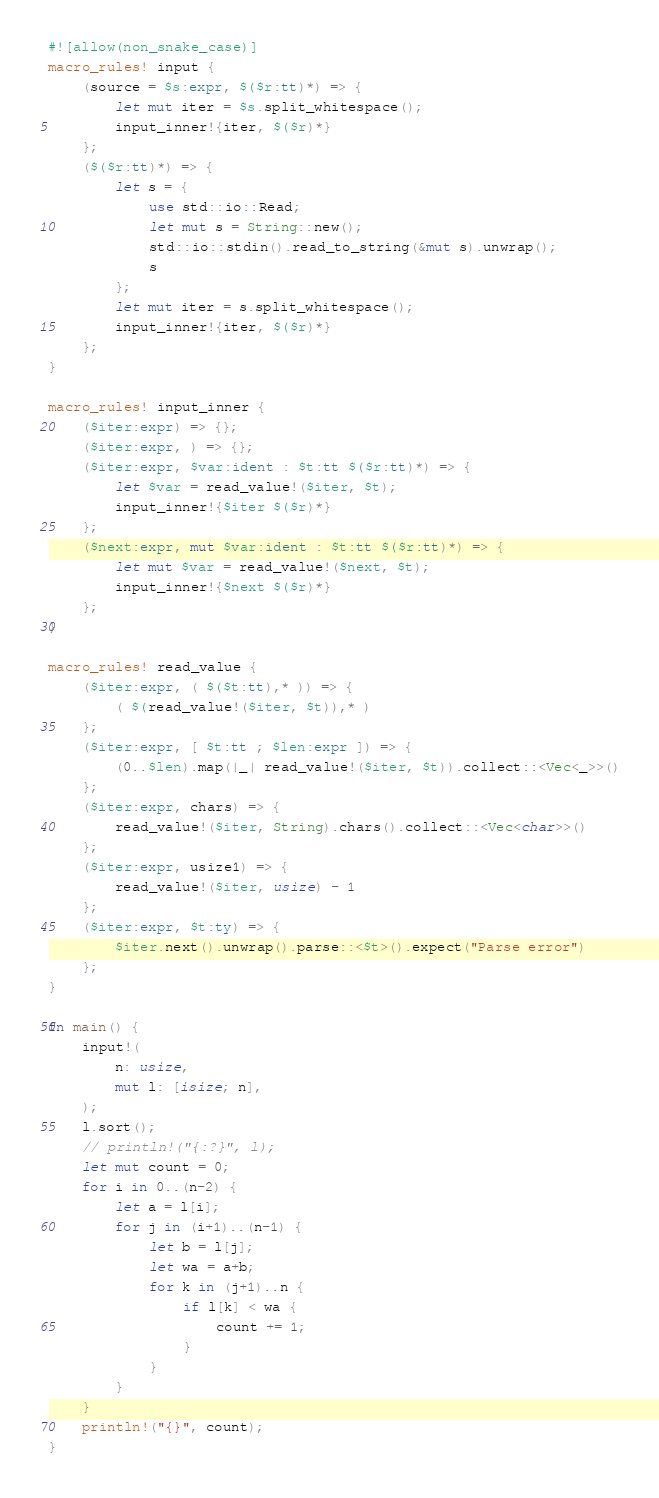<code> <loc_0><loc_0><loc_500><loc_500><_Rust_>#![allow(non_snake_case)]
macro_rules! input {
    (source = $s:expr, $($r:tt)*) => {
        let mut iter = $s.split_whitespace();
        input_inner!{iter, $($r)*}
    };
    ($($r:tt)*) => {
        let s = {
            use std::io::Read;
            let mut s = String::new();
            std::io::stdin().read_to_string(&mut s).unwrap();
            s
        };
        let mut iter = s.split_whitespace();
        input_inner!{iter, $($r)*}
    };
}

macro_rules! input_inner {
    ($iter:expr) => {};
    ($iter:expr, ) => {};
    ($iter:expr, $var:ident : $t:tt $($r:tt)*) => {
        let $var = read_value!($iter, $t);
        input_inner!{$iter $($r)*}
    };
    ($next:expr, mut $var:ident : $t:tt $($r:tt)*) => {
        let mut $var = read_value!($next, $t);
        input_inner!{$next $($r)*}
    };
}

macro_rules! read_value {
    ($iter:expr, ( $($t:tt),* )) => {
        ( $(read_value!($iter, $t)),* )
    };
    ($iter:expr, [ $t:tt ; $len:expr ]) => {
        (0..$len).map(|_| read_value!($iter, $t)).collect::<Vec<_>>()
    };
    ($iter:expr, chars) => {
        read_value!($iter, String).chars().collect::<Vec<char>>()
    };
    ($iter:expr, usize1) => {
        read_value!($iter, usize) - 1
    };
    ($iter:expr, $t:ty) => {
        $iter.next().unwrap().parse::<$t>().expect("Parse error")
    };
}

fn main() {
    input!(
        n: usize,
        mut l: [isize; n],
    );
    l.sort();
    // println!("{:?}", l);
    let mut count = 0;
    for i in 0..(n-2) {
        let a = l[i];
        for j in (i+1)..(n-1) {
            let b = l[j];
            let wa = a+b;
            for k in (j+1)..n {
                if l[k] < wa {
                    count += 1;
                }
            }
        }
    }
    println!("{}", count);
}
</code> 